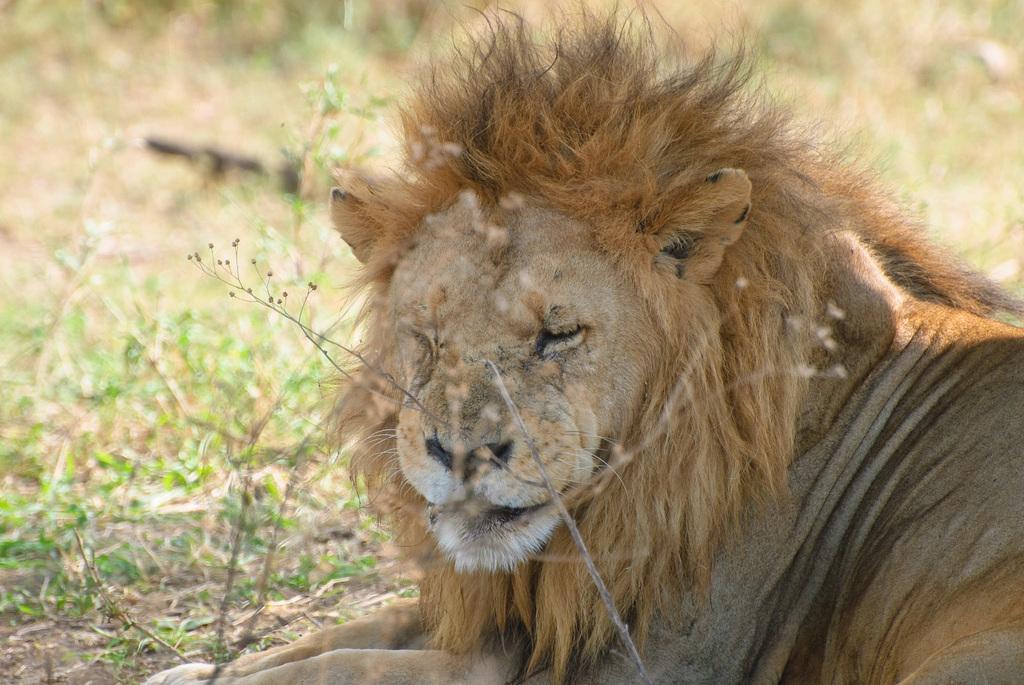How would you summarize this image in a sentence or two? In this image there is a lion. 